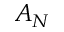<formula> <loc_0><loc_0><loc_500><loc_500>A _ { N }</formula> 